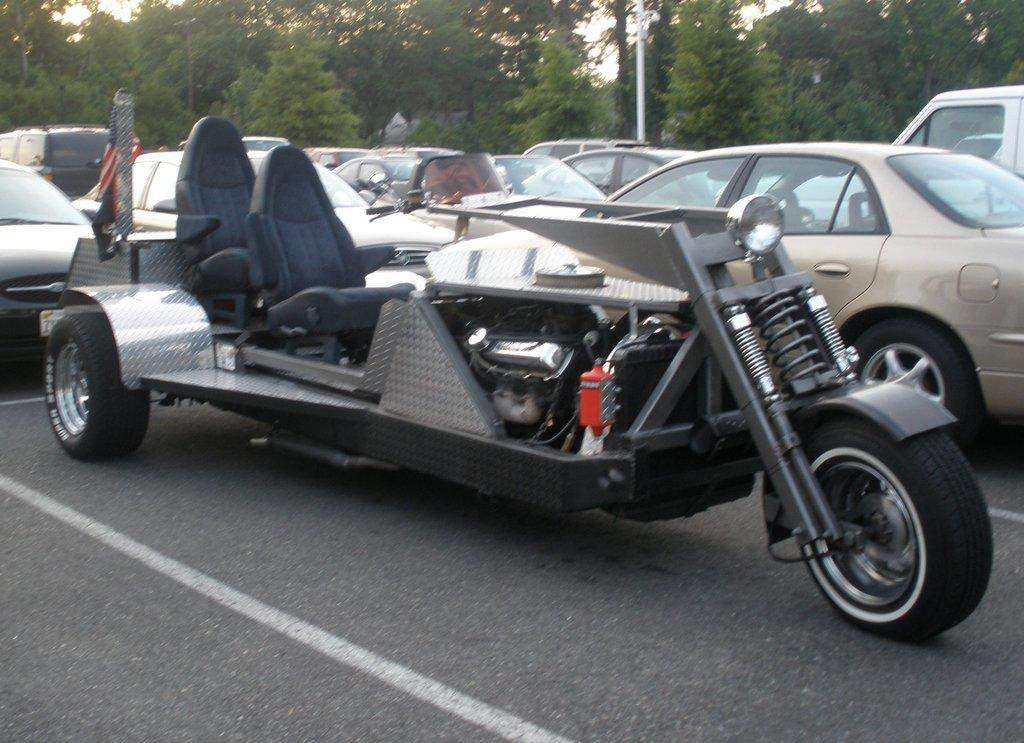What can be seen on the road in the image? There are vehicles on the road in the image. Are there any distinguishing features on any of the vehicles? Yes, there is a flag on one of the vehicles. What can be seen in the background of the image? There are trees, a pole, and the sky visible in the background of the image. What type of roof can be seen on the vehicles in the image? The image does not show the roofs of the vehicles, so it is not possible to determine their type. 